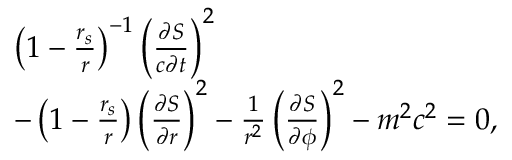Convert formula to latex. <formula><loc_0><loc_0><loc_500><loc_500>\begin{array} { l } { \left ( 1 - \frac { r _ { s } } { r } \right ) ^ { - 1 } \left ( \frac { \partial S } { c \partial t } \right ) ^ { 2 } } \\ { - \left ( 1 - \frac { r _ { s } } { r } \right ) \left ( \frac { \partial S } { \partial r } \right ) ^ { 2 } - \frac { 1 } { r ^ { 2 } } \left ( \frac { \partial S } { \partial \phi } \right ) ^ { 2 } - m ^ { 2 } c ^ { 2 } = 0 , } \end{array}</formula> 